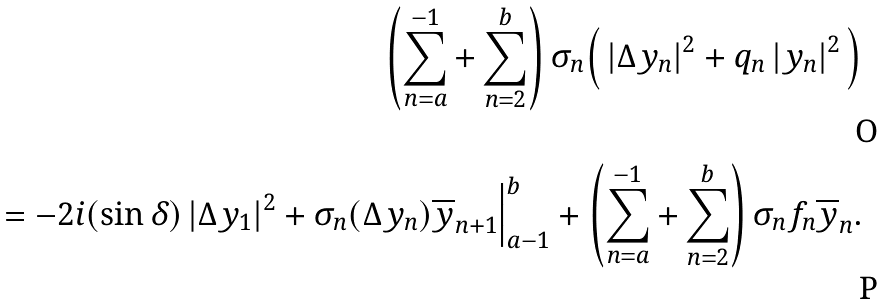Convert formula to latex. <formula><loc_0><loc_0><loc_500><loc_500>\left ( \sum _ { n = a } ^ { - 1 } + \sum _ { n = 2 } ^ { b } \right ) \sigma _ { n } \Big ( \left | \Delta y _ { n } \right | ^ { 2 } + q _ { n } \left | y _ { n } \right | ^ { 2 } \Big ) \\ = - 2 i ( \sin \delta ) \left | \Delta y _ { 1 } \right | ^ { 2 } + \sigma _ { n } ( \Delta y _ { n } ) \overline { y } _ { n + 1 } \Big | _ { a - 1 } ^ { b } + \left ( \sum _ { n = a } ^ { - 1 } + \sum _ { n = 2 } ^ { b } \right ) \sigma _ { n } f _ { n } \overline { y } _ { n } .</formula> 